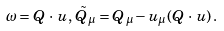Convert formula to latex. <formula><loc_0><loc_0><loc_500><loc_500>\omega = Q \, \cdot \, u , \, \tilde { Q } _ { \mu } = Q _ { \mu } - u _ { \mu } ( Q \, \cdot \, u ) \, .</formula> 